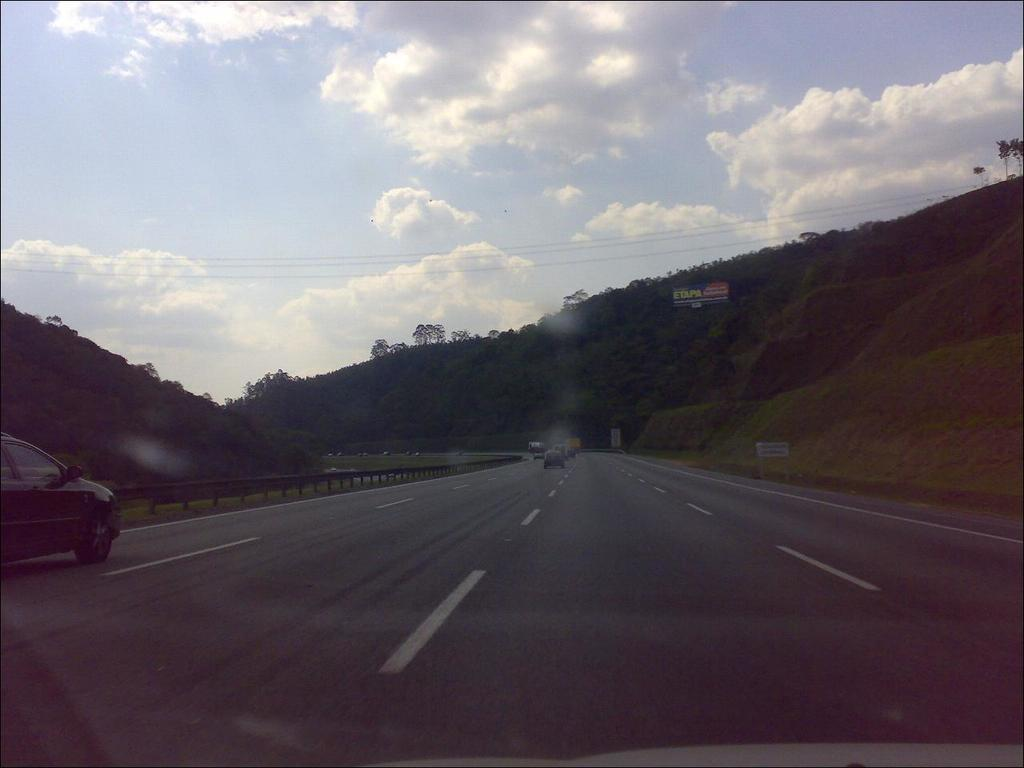What can be seen on the road in the image? There are vehicles on the road in the image. What type of natural elements are present in the image? There are trees and mountains in the image. What type of advertisement is visible in the image? There is a hoarding in the image. What is visible in the background of the image? The sky is visible in the background of the image, and clouds are present in the sky. Can you tell me how many knee pads are visible on the vehicles in the image? There are no knee pads visible on the vehicles in the image. What type of jellyfish can be seen swimming in the sky in the image? There are no jellyfish present in the image; it features vehicles on the road, trees, mountains, a hoarding, and a sky with clouds. 